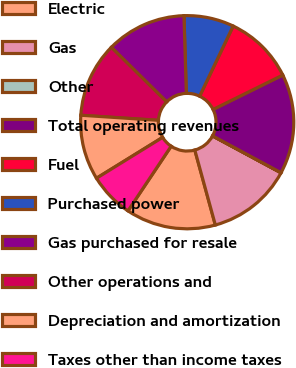<chart> <loc_0><loc_0><loc_500><loc_500><pie_chart><fcel>Electric<fcel>Gas<fcel>Other<fcel>Total operating revenues<fcel>Fuel<fcel>Purchased power<fcel>Gas purchased for resale<fcel>Other operations and<fcel>Depreciation and amortization<fcel>Taxes other than income taxes<nl><fcel>13.63%<fcel>12.88%<fcel>0.01%<fcel>15.15%<fcel>10.61%<fcel>7.58%<fcel>12.12%<fcel>11.36%<fcel>9.85%<fcel>6.82%<nl></chart> 